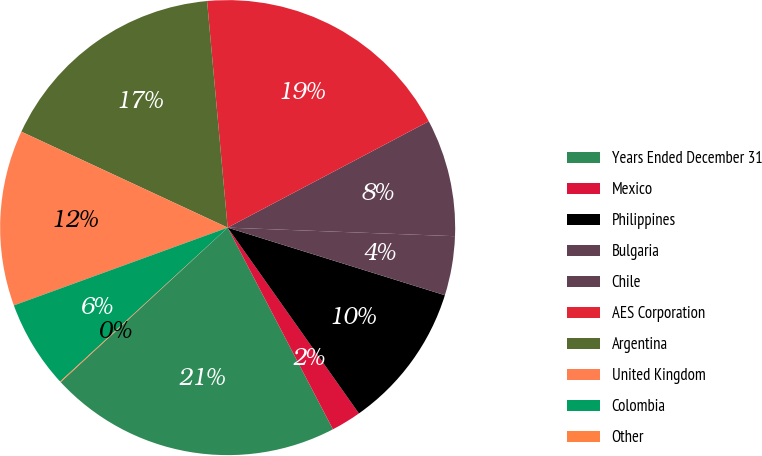Convert chart. <chart><loc_0><loc_0><loc_500><loc_500><pie_chart><fcel>Years Ended December 31<fcel>Mexico<fcel>Philippines<fcel>Bulgaria<fcel>Chile<fcel>AES Corporation<fcel>Argentina<fcel>United Kingdom<fcel>Colombia<fcel>Other<nl><fcel>20.77%<fcel>2.13%<fcel>10.41%<fcel>4.2%<fcel>8.34%<fcel>18.7%<fcel>16.63%<fcel>12.48%<fcel>6.27%<fcel>0.06%<nl></chart> 